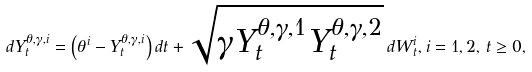<formula> <loc_0><loc_0><loc_500><loc_500>d Y ^ { \theta , \gamma , i } _ { t } = \left ( \theta ^ { i } - Y ^ { \theta , \gamma , i } _ { t } \right ) d t + \sqrt { \gamma Y ^ { \theta , \gamma , 1 } _ { t } Y ^ { \theta , \gamma , 2 } _ { t } } \, d W ^ { i } _ { t } , i = 1 , 2 , \, t \geq 0 ,</formula> 